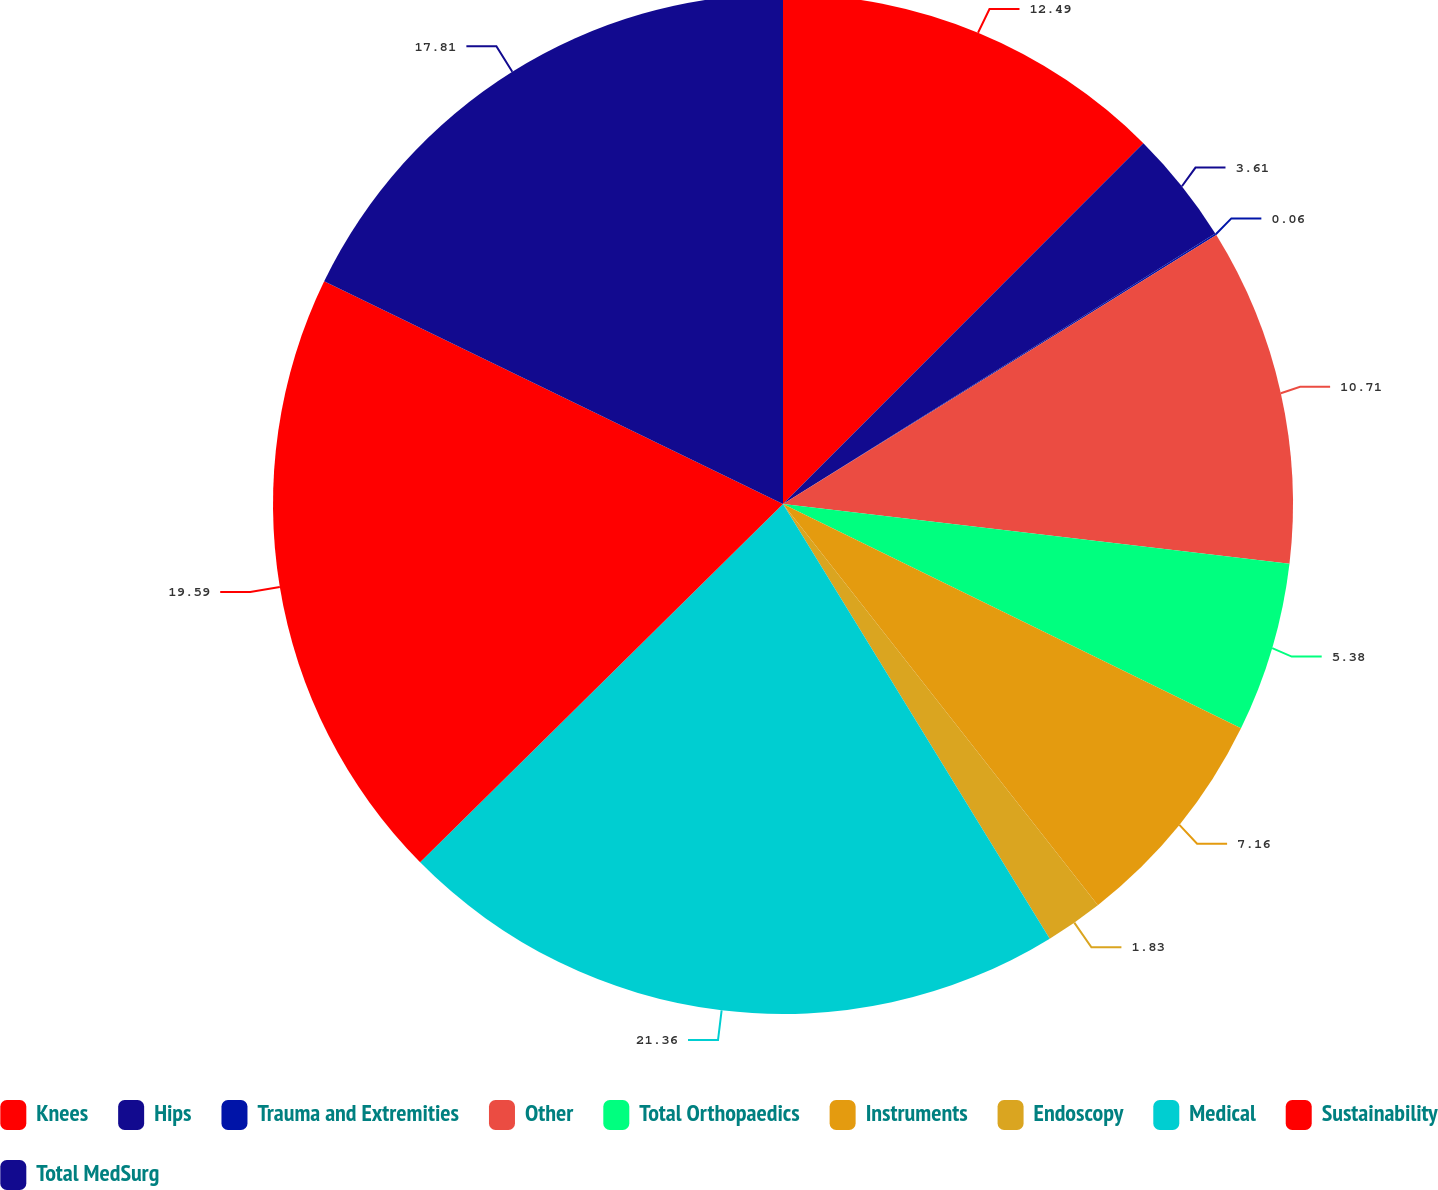Convert chart. <chart><loc_0><loc_0><loc_500><loc_500><pie_chart><fcel>Knees<fcel>Hips<fcel>Trauma and Extremities<fcel>Other<fcel>Total Orthopaedics<fcel>Instruments<fcel>Endoscopy<fcel>Medical<fcel>Sustainability<fcel>Total MedSurg<nl><fcel>12.49%<fcel>3.61%<fcel>0.06%<fcel>10.71%<fcel>5.38%<fcel>7.16%<fcel>1.83%<fcel>21.36%<fcel>19.59%<fcel>17.81%<nl></chart> 